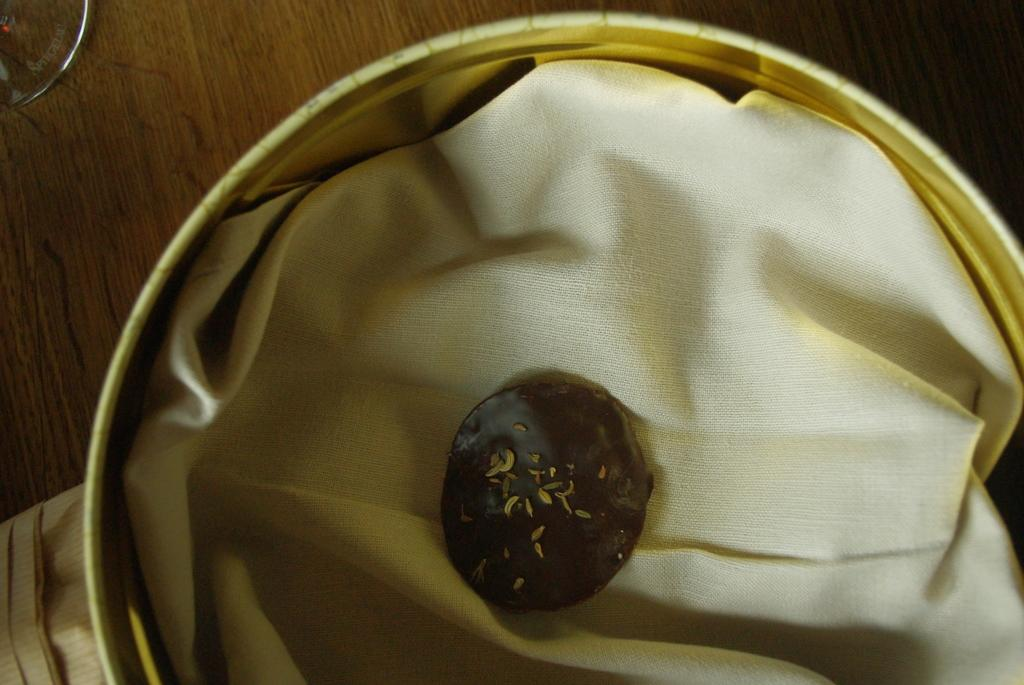What type of cookie is in the image? There is a brown cookie in the image. Where is the brown cookie placed? The brown cookie is kept in a golden bowl. Can you see any horses or caves in the image? No, there are no horses or caves present in the image. The image only features a brown cookie in a golden bowl. 